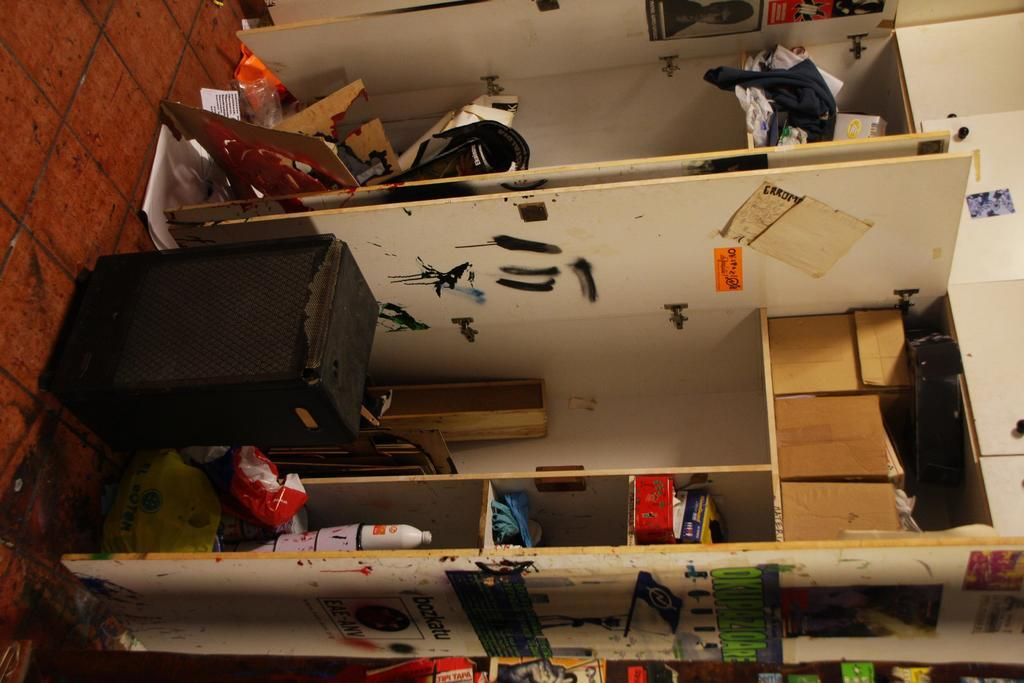What is the main object in the image? There is a rack in the image. What is placed on the rack? There are things placed in the rack. What other objects can be seen in the image? There are boxes in the image. Where is the speaker located in the image? There is a speaker at the bottom of the image. What is on the wall in the image? There are posters on the wall. Can you tell me how many toads are sitting on the speaker in the image? There are no toads present in the image; the speaker is located at the bottom of the image. What type of beef is being cooked in the image? There is no beef or cooking activity present in the image. 